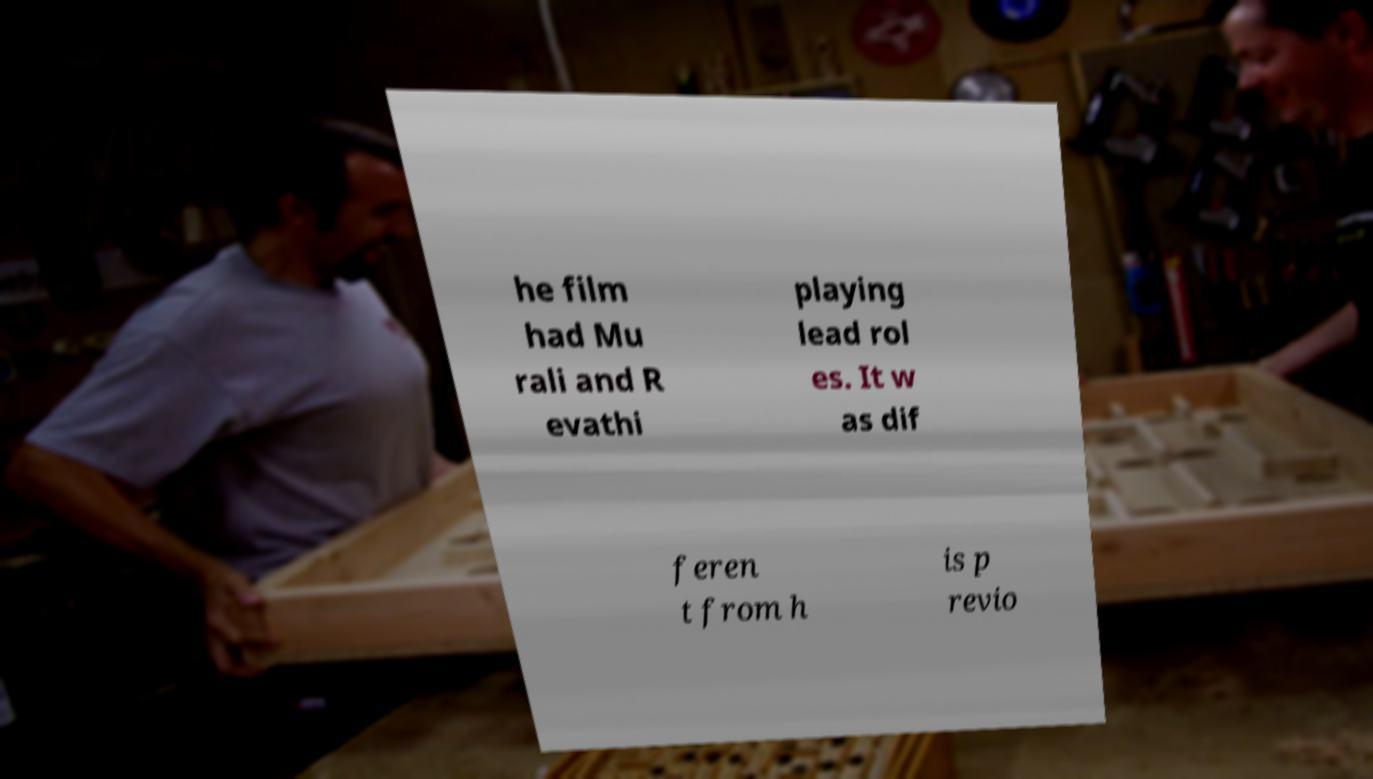What messages or text are displayed in this image? I need them in a readable, typed format. he film had Mu rali and R evathi playing lead rol es. It w as dif feren t from h is p revio 